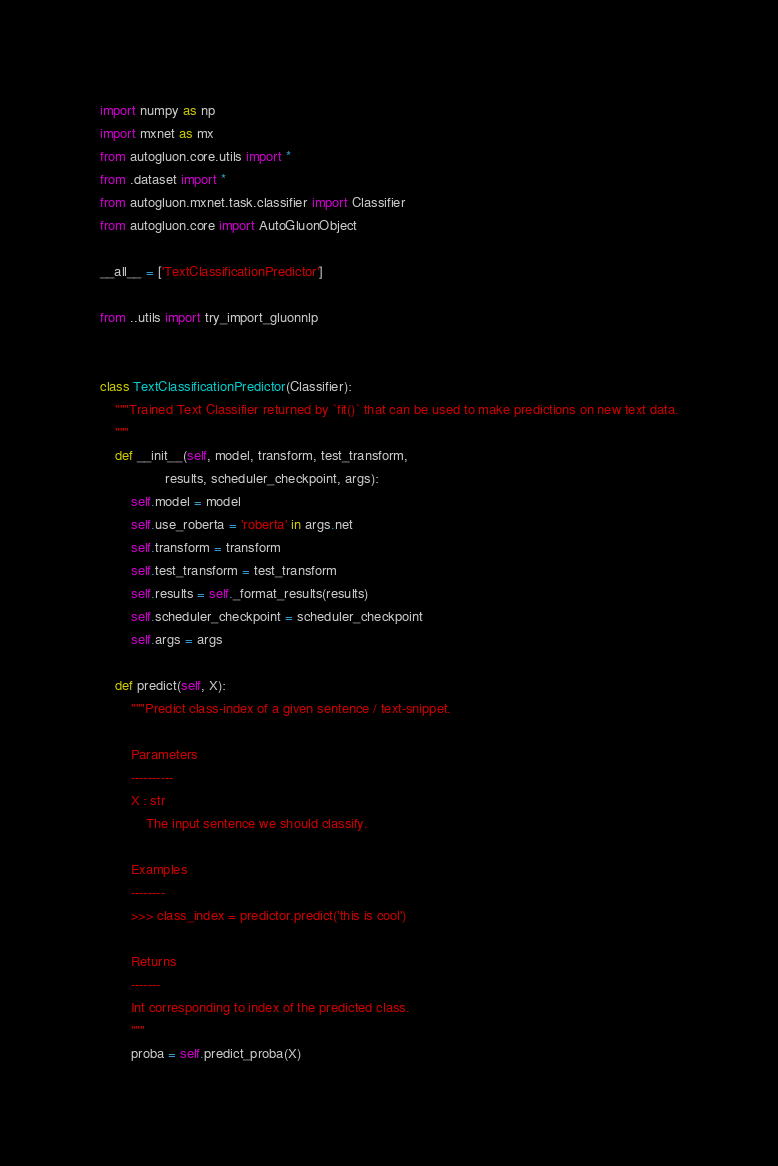<code> <loc_0><loc_0><loc_500><loc_500><_Python_>import numpy as np
import mxnet as mx
from autogluon.core.utils import *
from .dataset import *
from autogluon.mxnet.task.classifier import Classifier
from autogluon.core import AutoGluonObject

__all__ = ['TextClassificationPredictor']

from ..utils import try_import_gluonnlp


class TextClassificationPredictor(Classifier):
    """Trained Text Classifier returned by `fit()` that can be used to make predictions on new text data.
    """
    def __init__(self, model, transform, test_transform,
                 results, scheduler_checkpoint, args):
        self.model = model
        self.use_roberta = 'roberta' in args.net
        self.transform = transform
        self.test_transform = test_transform
        self.results = self._format_results(results)
        self.scheduler_checkpoint = scheduler_checkpoint
        self.args = args

    def predict(self, X):
        """Predict class-index of a given sentence / text-snippet.
        
        Parameters
        ----------
        X : str
            The input sentence we should classify.
    
        Examples
        --------
        >>> class_index = predictor.predict('this is cool')
    
        Returns
        -------
        Int corresponding to index of the predicted class.
        """
        proba = self.predict_proba(X)</code> 